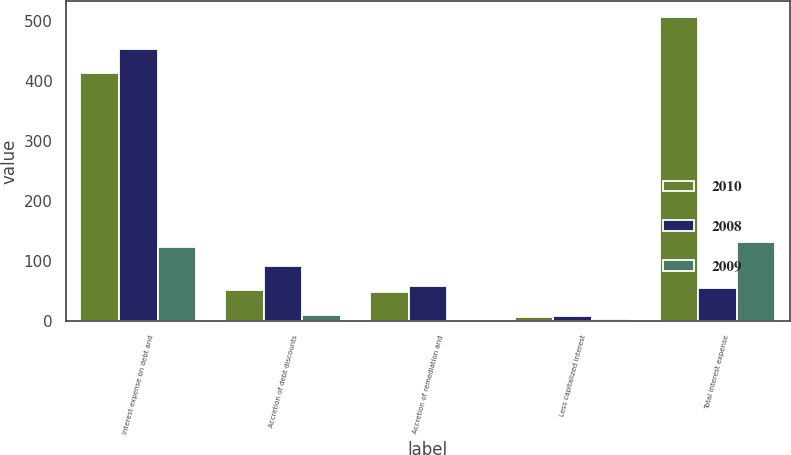<chart> <loc_0><loc_0><loc_500><loc_500><stacked_bar_chart><ecel><fcel>Interest expense on debt and<fcel>Accretion of debt discounts<fcel>Accretion of remediation and<fcel>Less capitalized interest<fcel>Total interest expense<nl><fcel>2010<fcel>413.2<fcel>52.4<fcel>48.1<fcel>6.3<fcel>507.4<nl><fcel>2008<fcel>453.5<fcel>92.1<fcel>58.1<fcel>7.8<fcel>55.25<nl><fcel>2009<fcel>123.9<fcel>10.1<fcel>0.5<fcel>2.6<fcel>131.9<nl></chart> 